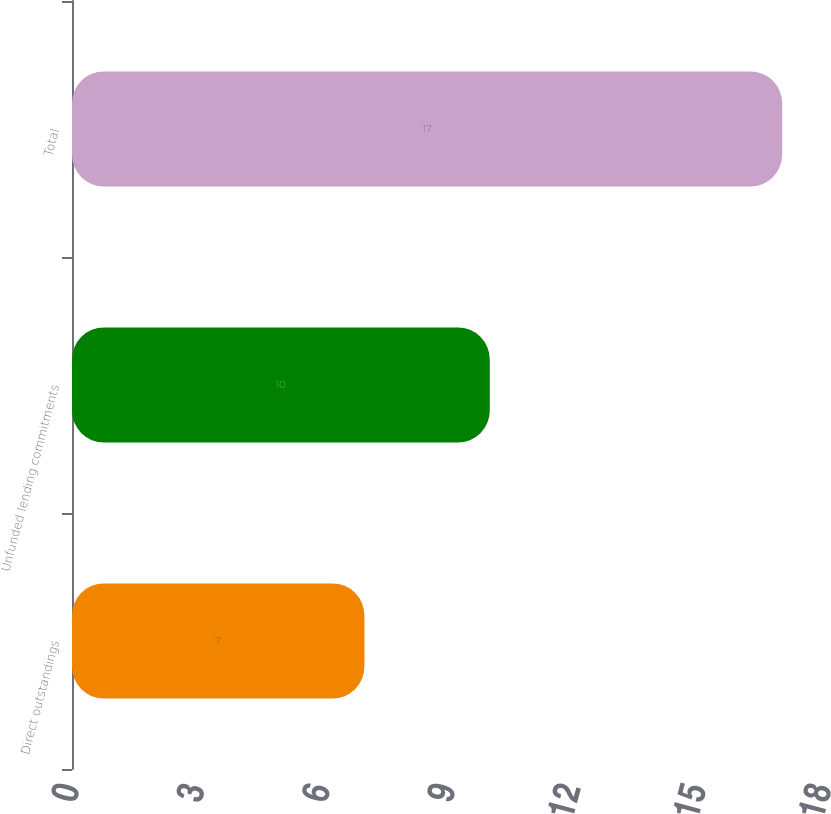Convert chart to OTSL. <chart><loc_0><loc_0><loc_500><loc_500><bar_chart><fcel>Direct outstandings<fcel>Unfunded lending commitments<fcel>Total<nl><fcel>7<fcel>10<fcel>17<nl></chart> 